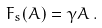Convert formula to latex. <formula><loc_0><loc_0><loc_500><loc_500>F _ { s } ( A ) = \gamma A \, .</formula> 